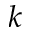Convert formula to latex. <formula><loc_0><loc_0><loc_500><loc_500>k</formula> 